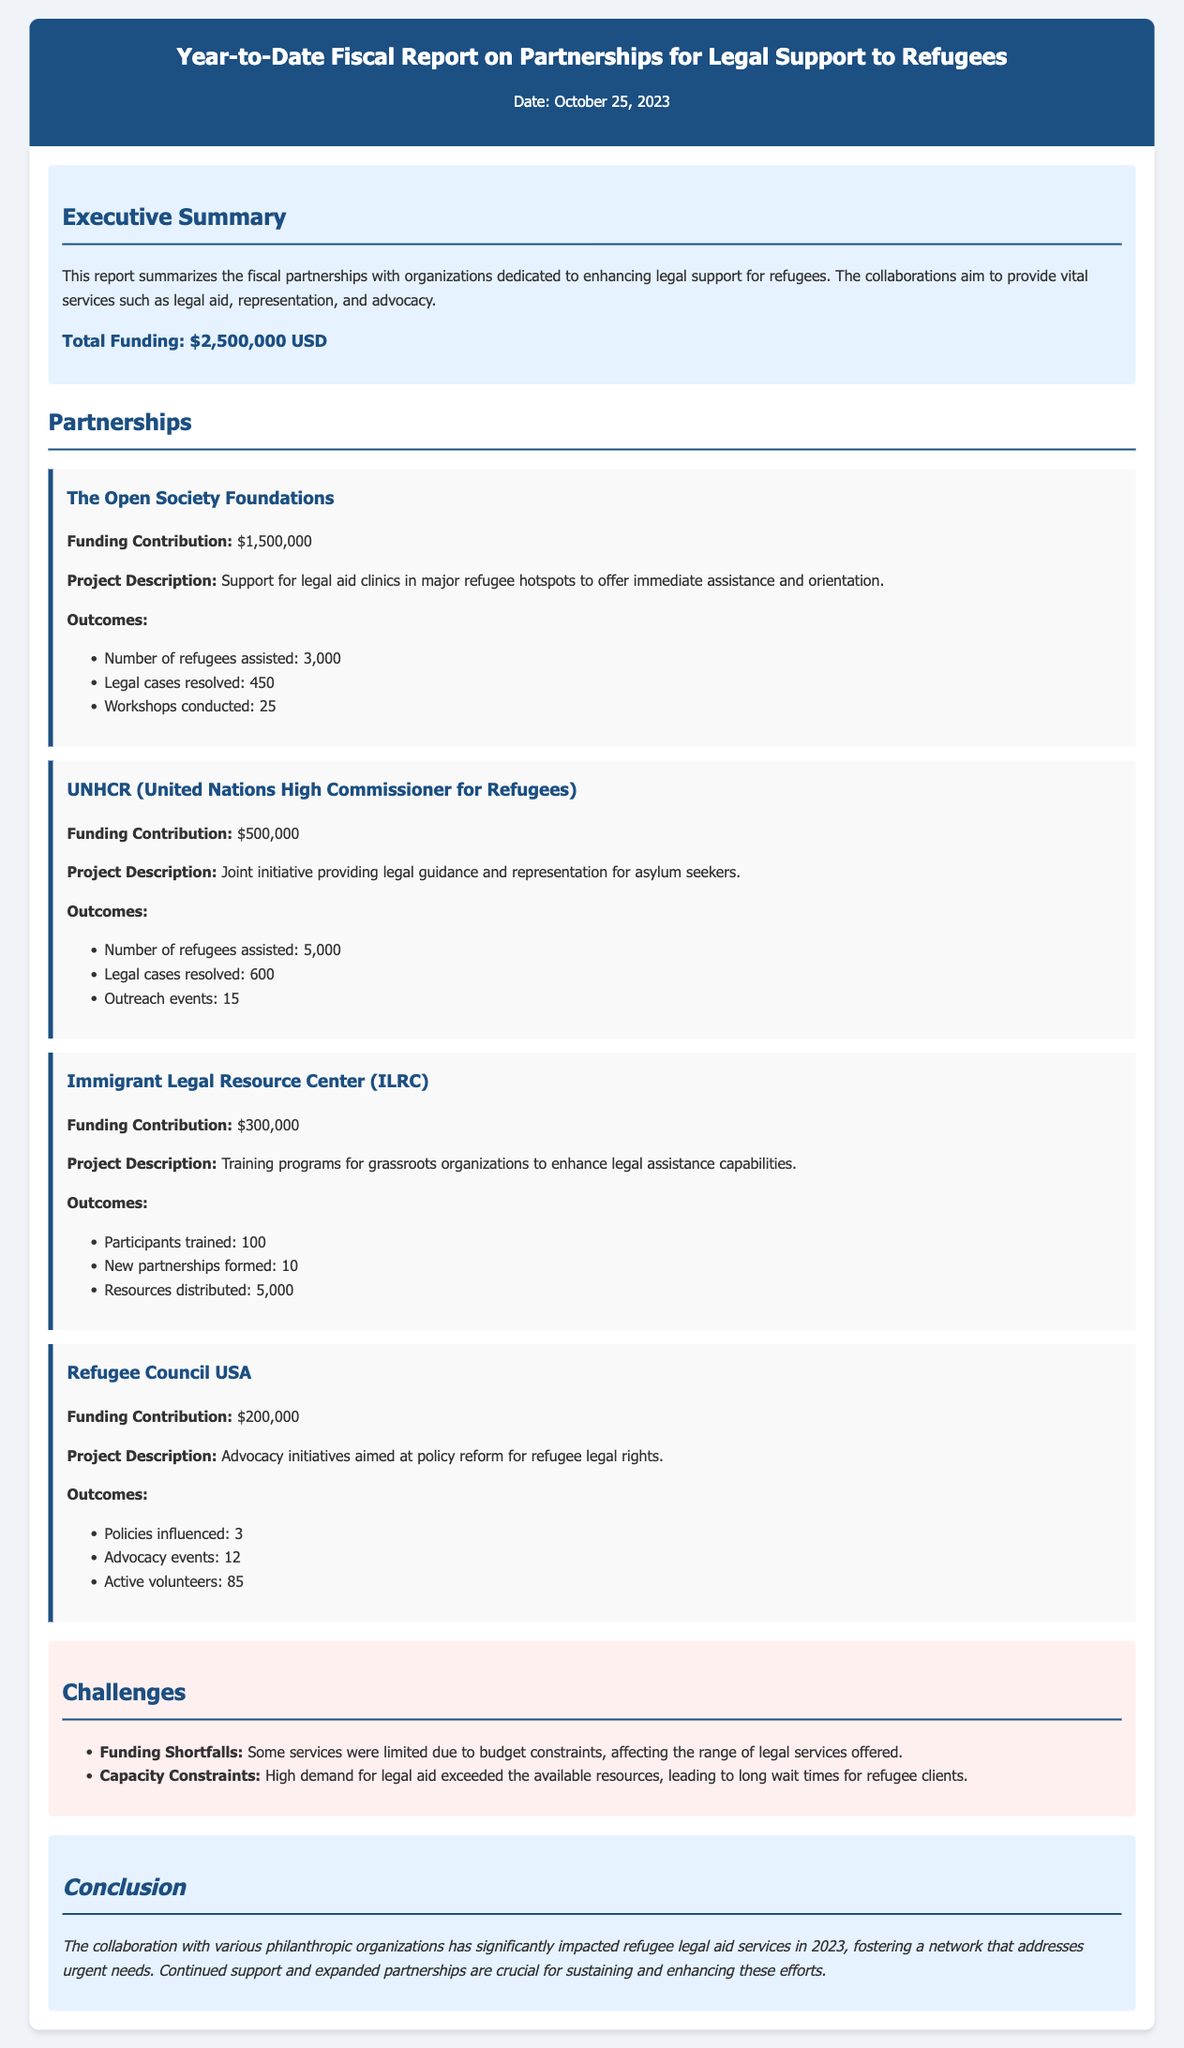What is the total funding? The total funding is stated in the executive summary as $2,500,000 USD.
Answer: $2,500,000 USD How much did The Open Society Foundations contribute? The contribution from The Open Society Foundations is specified as $1,500,000.
Answer: $1,500,000 How many refugees were assisted by UNHCR? The document lists the number of refugees assisted by UNHCR as 5,000.
Answer: 5,000 What was the outcome of advocacy initiatives by Refugee Council USA? The document states that 3 policies were influenced by advocacy initiatives.
Answer: 3 What type of project did the Immigrant Legal Resource Center focus on? The project was on training programs for grassroots organizations.
Answer: Training programs for grassroots organizations What challenges are mentioned in the report? Two specific challenges are outlined: funding shortfalls and capacity constraints.
Answer: Funding shortfalls and capacity constraints How many workshops were conducted by The Open Society Foundations? The number of workshops conducted is mentioned as 25.
Answer: 25 What is the conclusion of the report? The conclusion emphasizes the significant impact of collaboration with various organizations on refugee legal aid services.
Answer: Significant impact of collaboration How many participants were trained by ILRC? The document specifies that 100 participants were trained.
Answer: 100 